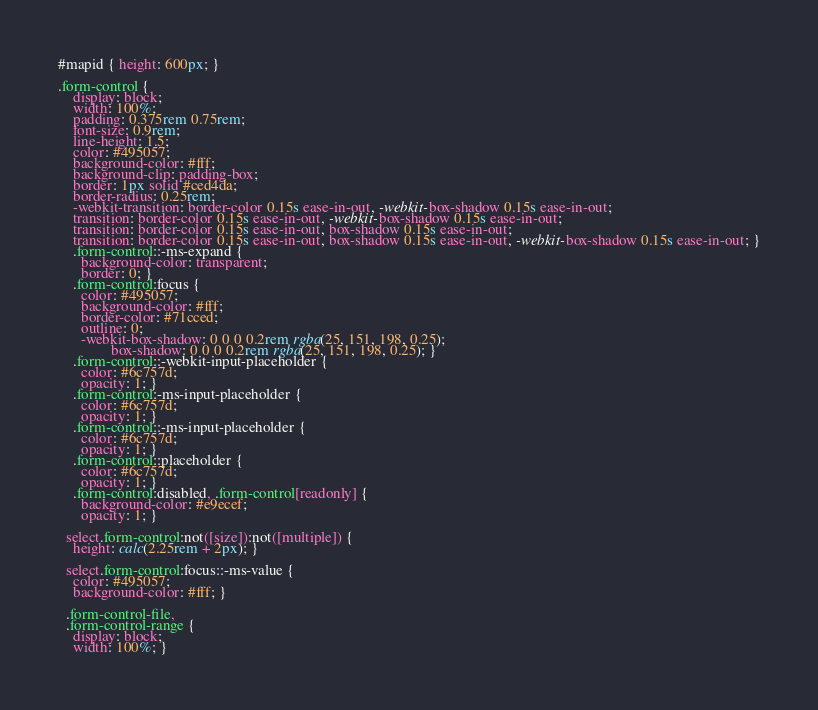Convert code to text. <code><loc_0><loc_0><loc_500><loc_500><_CSS_>#mapid { height: 600px; }

.form-control {
    display: block;
    width: 100%;
    padding: 0.375rem 0.75rem;
    font-size: 0.9rem;
    line-height: 1.5;
    color: #495057;
    background-color: #fff;
    background-clip: padding-box;
    border: 1px solid #ced4da;
    border-radius: 0.25rem;
    -webkit-transition: border-color 0.15s ease-in-out, -webkit-box-shadow 0.15s ease-in-out;
    transition: border-color 0.15s ease-in-out, -webkit-box-shadow 0.15s ease-in-out;
    transition: border-color 0.15s ease-in-out, box-shadow 0.15s ease-in-out;
    transition: border-color 0.15s ease-in-out, box-shadow 0.15s ease-in-out, -webkit-box-shadow 0.15s ease-in-out; }
    .form-control::-ms-expand {
      background-color: transparent;
      border: 0; }
    .form-control:focus {
      color: #495057;
      background-color: #fff;
      border-color: #71cced;
      outline: 0;
      -webkit-box-shadow: 0 0 0 0.2rem rgba(25, 151, 198, 0.25);
              box-shadow: 0 0 0 0.2rem rgba(25, 151, 198, 0.25); }
    .form-control::-webkit-input-placeholder {
      color: #6c757d;
      opacity: 1; }
    .form-control:-ms-input-placeholder {
      color: #6c757d;
      opacity: 1; }
    .form-control::-ms-input-placeholder {
      color: #6c757d;
      opacity: 1; }
    .form-control::placeholder {
      color: #6c757d;
      opacity: 1; }
    .form-control:disabled, .form-control[readonly] {
      background-color: #e9ecef;
      opacity: 1; }
  
  select.form-control:not([size]):not([multiple]) {
    height: calc(2.25rem + 2px); }
  
  select.form-control:focus::-ms-value {
    color: #495057;
    background-color: #fff; }
  
  .form-control-file,
  .form-control-range {
    display: block;
    width: 100%; }</code> 